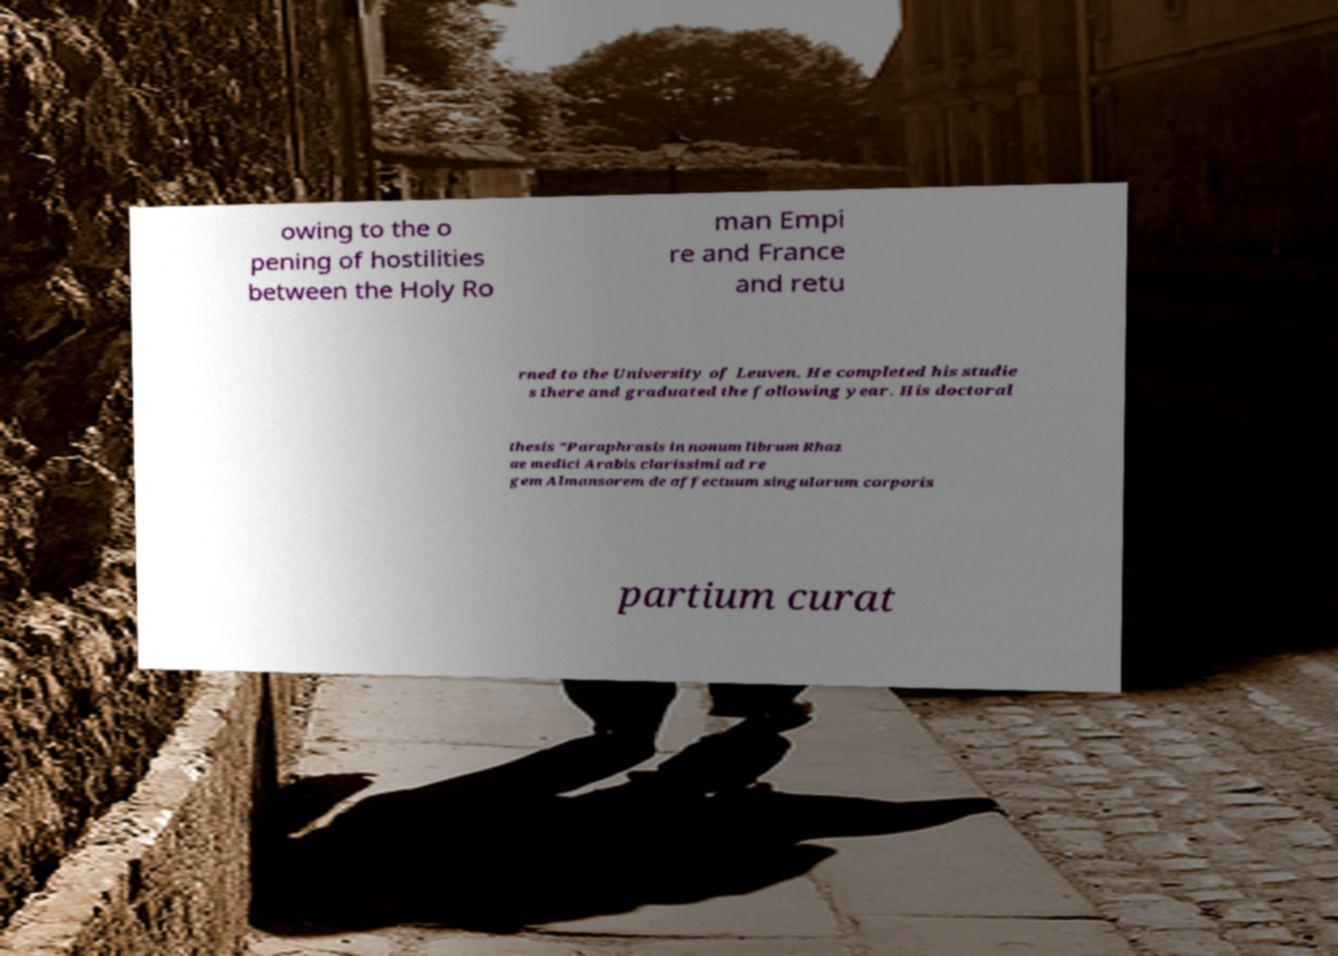What messages or text are displayed in this image? I need them in a readable, typed format. owing to the o pening of hostilities between the Holy Ro man Empi re and France and retu rned to the University of Leuven. He completed his studie s there and graduated the following year. His doctoral thesis "Paraphrasis in nonum librum Rhaz ae medici Arabis clarissimi ad re gem Almansorem de affectuum singularum corporis partium curat 